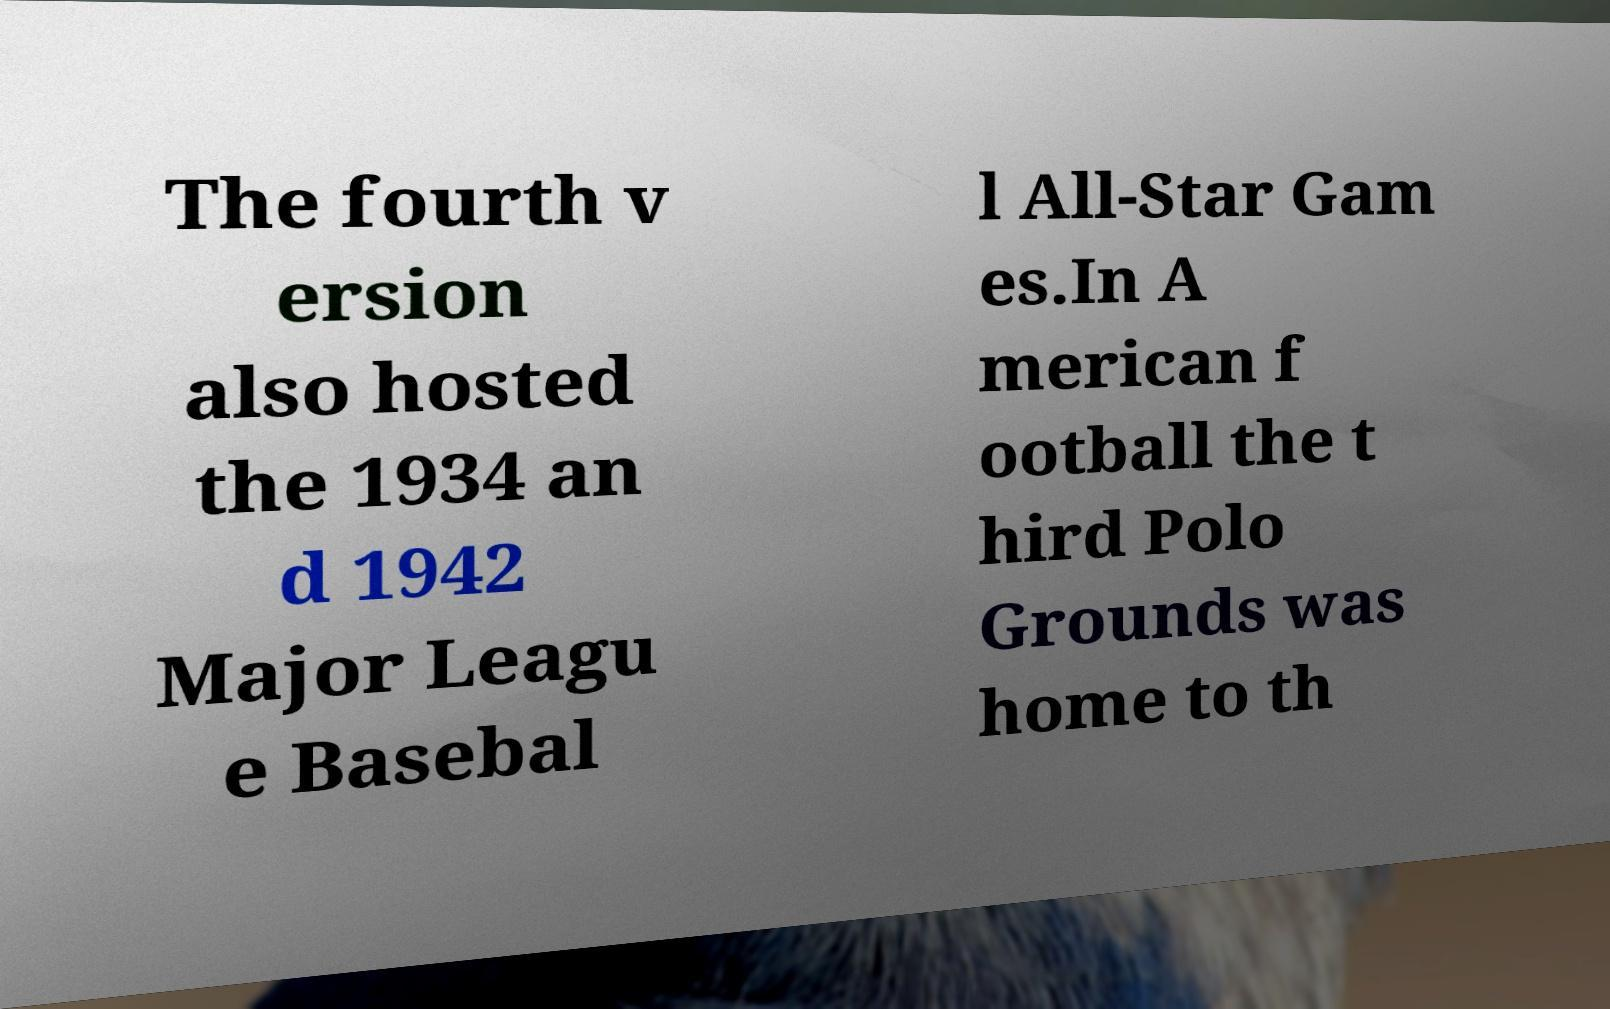Could you assist in decoding the text presented in this image and type it out clearly? The fourth v ersion also hosted the 1934 an d 1942 Major Leagu e Basebal l All-Star Gam es.In A merican f ootball the t hird Polo Grounds was home to th 